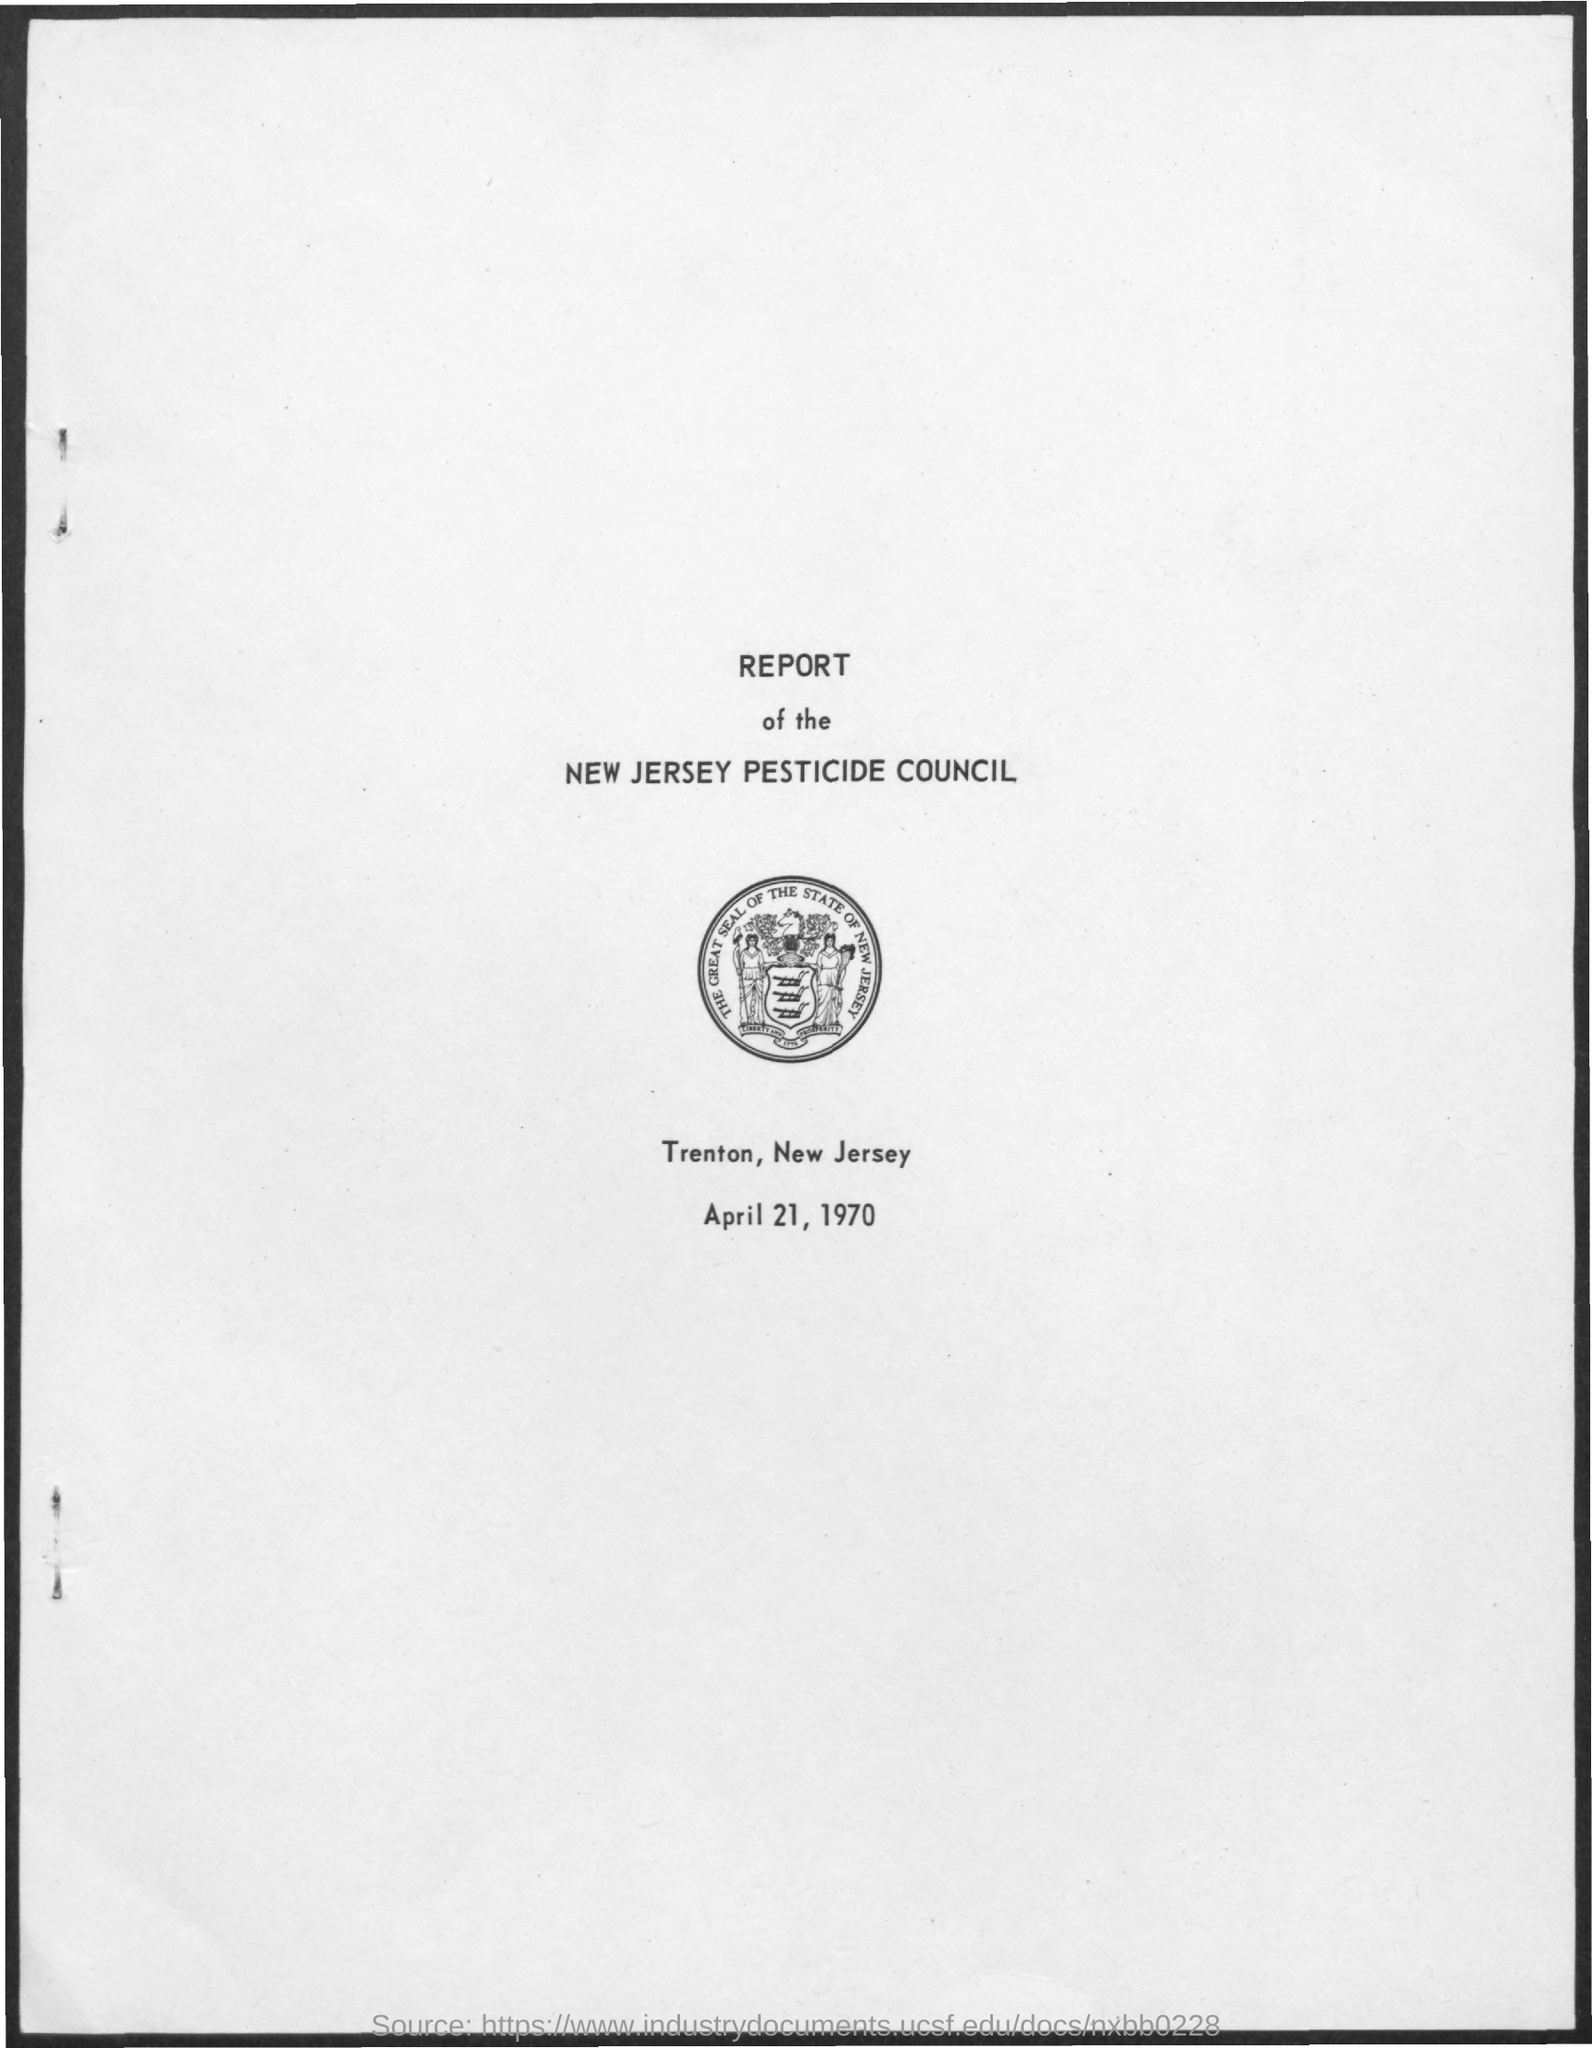Highlight a few significant elements in this photo. The report is owned by the New Jersey Pesticide Council. The date on the document is April 21, 1970. 